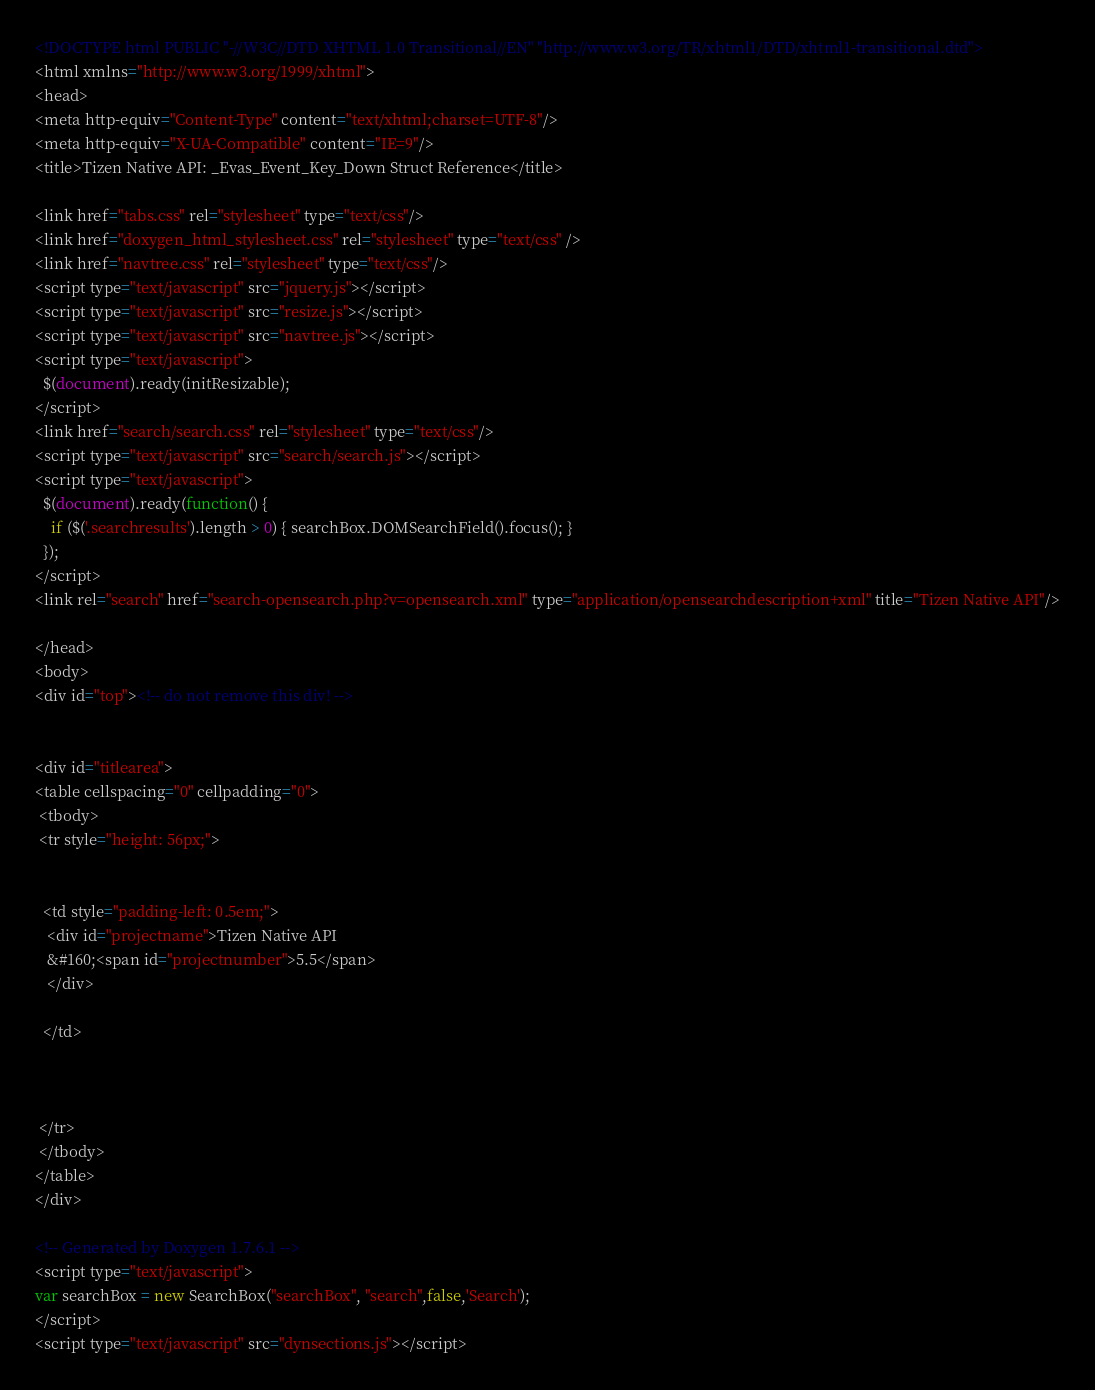<code> <loc_0><loc_0><loc_500><loc_500><_HTML_><!DOCTYPE html PUBLIC "-//W3C//DTD XHTML 1.0 Transitional//EN" "http://www.w3.org/TR/xhtml1/DTD/xhtml1-transitional.dtd">
<html xmlns="http://www.w3.org/1999/xhtml">
<head>
<meta http-equiv="Content-Type" content="text/xhtml;charset=UTF-8"/>
<meta http-equiv="X-UA-Compatible" content="IE=9"/>
<title>Tizen Native API: _Evas_Event_Key_Down Struct Reference</title>

<link href="tabs.css" rel="stylesheet" type="text/css"/>
<link href="doxygen_html_stylesheet.css" rel="stylesheet" type="text/css" />
<link href="navtree.css" rel="stylesheet" type="text/css"/>
<script type="text/javascript" src="jquery.js"></script>
<script type="text/javascript" src="resize.js"></script>
<script type="text/javascript" src="navtree.js"></script>
<script type="text/javascript">
  $(document).ready(initResizable);
</script>
<link href="search/search.css" rel="stylesheet" type="text/css"/>
<script type="text/javascript" src="search/search.js"></script>
<script type="text/javascript">
  $(document).ready(function() {
    if ($('.searchresults').length > 0) { searchBox.DOMSearchField().focus(); }
  });
</script>
<link rel="search" href="search-opensearch.php?v=opensearch.xml" type="application/opensearchdescription+xml" title="Tizen Native API"/>

</head>
<body>
<div id="top"><!-- do not remove this div! -->


<div id="titlearea">
<table cellspacing="0" cellpadding="0">
 <tbody>
 <tr style="height: 56px;">
  
  
  <td style="padding-left: 0.5em;">
   <div id="projectname">Tizen Native API
   &#160;<span id="projectnumber">5.5</span>
   </div>
   
  </td>
  
  
  
 </tr>
 </tbody>
</table>
</div>

<!-- Generated by Doxygen 1.7.6.1 -->
<script type="text/javascript">
var searchBox = new SearchBox("searchBox", "search",false,'Search');
</script>
<script type="text/javascript" src="dynsections.js"></script></code> 